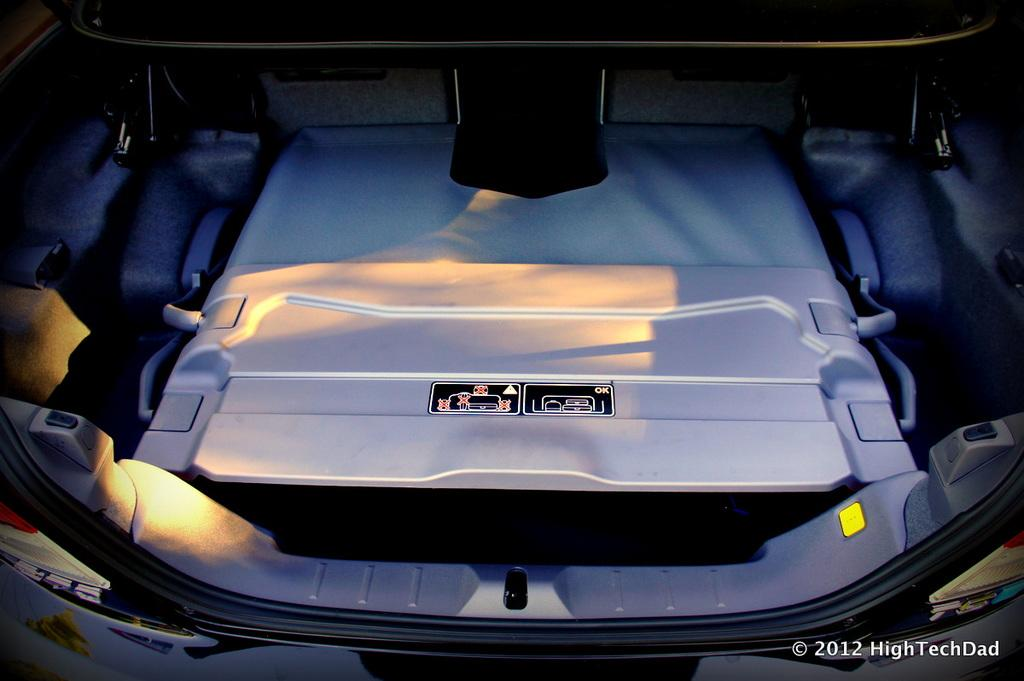What is the main subject of the image? The main subject of the image is the trunk of a vehicle. Is there any text present in the image? Yes, there is some text at the right bottom of the image. How does the heat affect the property in the image? There is no mention of heat or property in the image, so it cannot be determined how heat affects the property. 